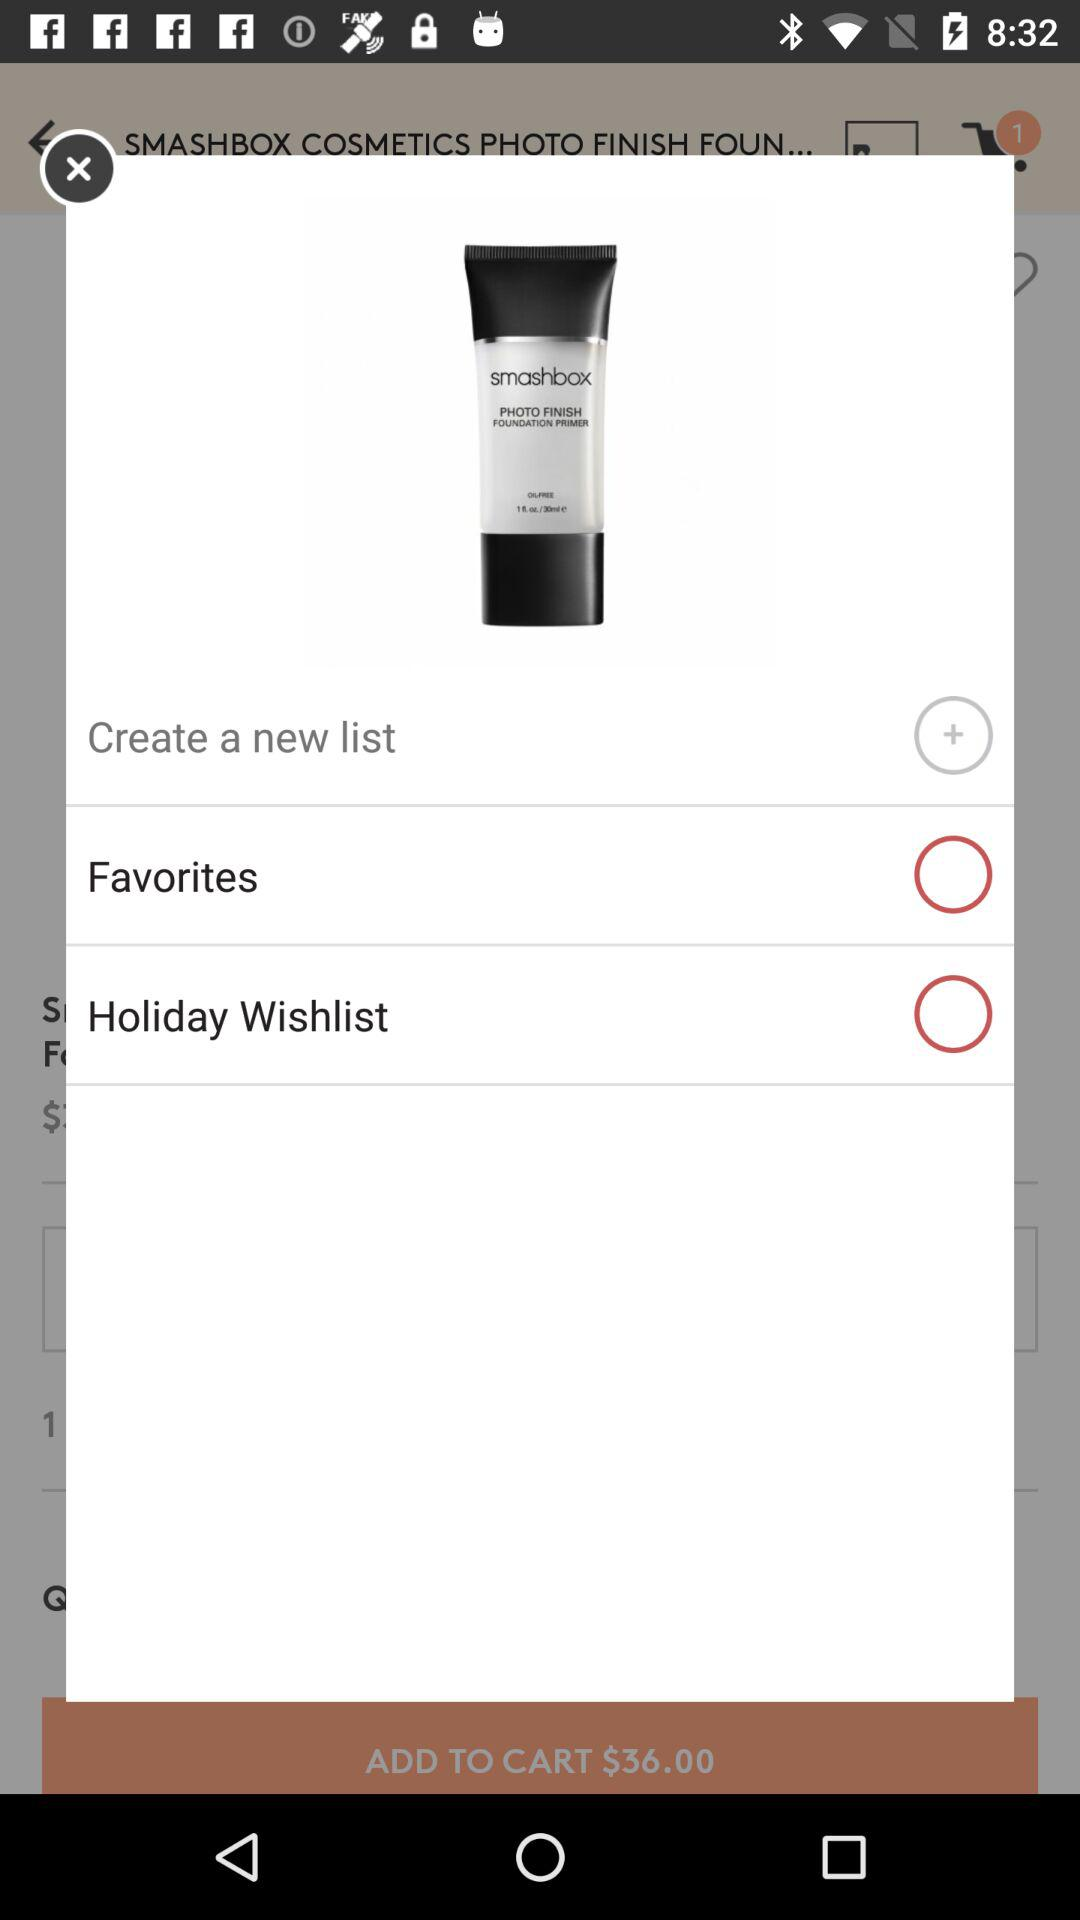What is the number of items showing in the cart? There is 1 item in the cart. 